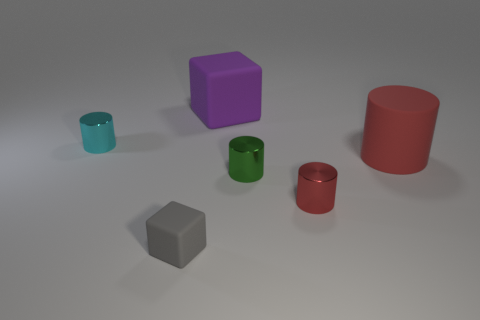Do the big matte thing left of the red rubber thing and the rubber object that is in front of the green object have the same shape?
Make the answer very short. Yes. There is a large matte cylinder; is its color the same as the small cylinder that is in front of the green metallic cylinder?
Provide a short and direct response. Yes. There is a shiny cylinder that is right of the small green metallic object; is it the same color as the big cylinder?
Make the answer very short. Yes. How many things are either tiny red matte blocks or matte objects that are in front of the tiny red cylinder?
Provide a succinct answer. 1. The thing that is both in front of the green metal thing and right of the large rubber block is made of what material?
Provide a short and direct response. Metal. There is a tiny cylinder left of the small rubber thing; what material is it?
Ensure brevity in your answer.  Metal. What is the color of the cylinder that is made of the same material as the small gray block?
Provide a succinct answer. Red. Do the red rubber object and the tiny metallic object to the left of the tiny block have the same shape?
Give a very brief answer. Yes. Are there any purple matte things right of the tiny cube?
Offer a very short reply. Yes. What material is the other tiny cylinder that is the same color as the matte cylinder?
Provide a short and direct response. Metal. 